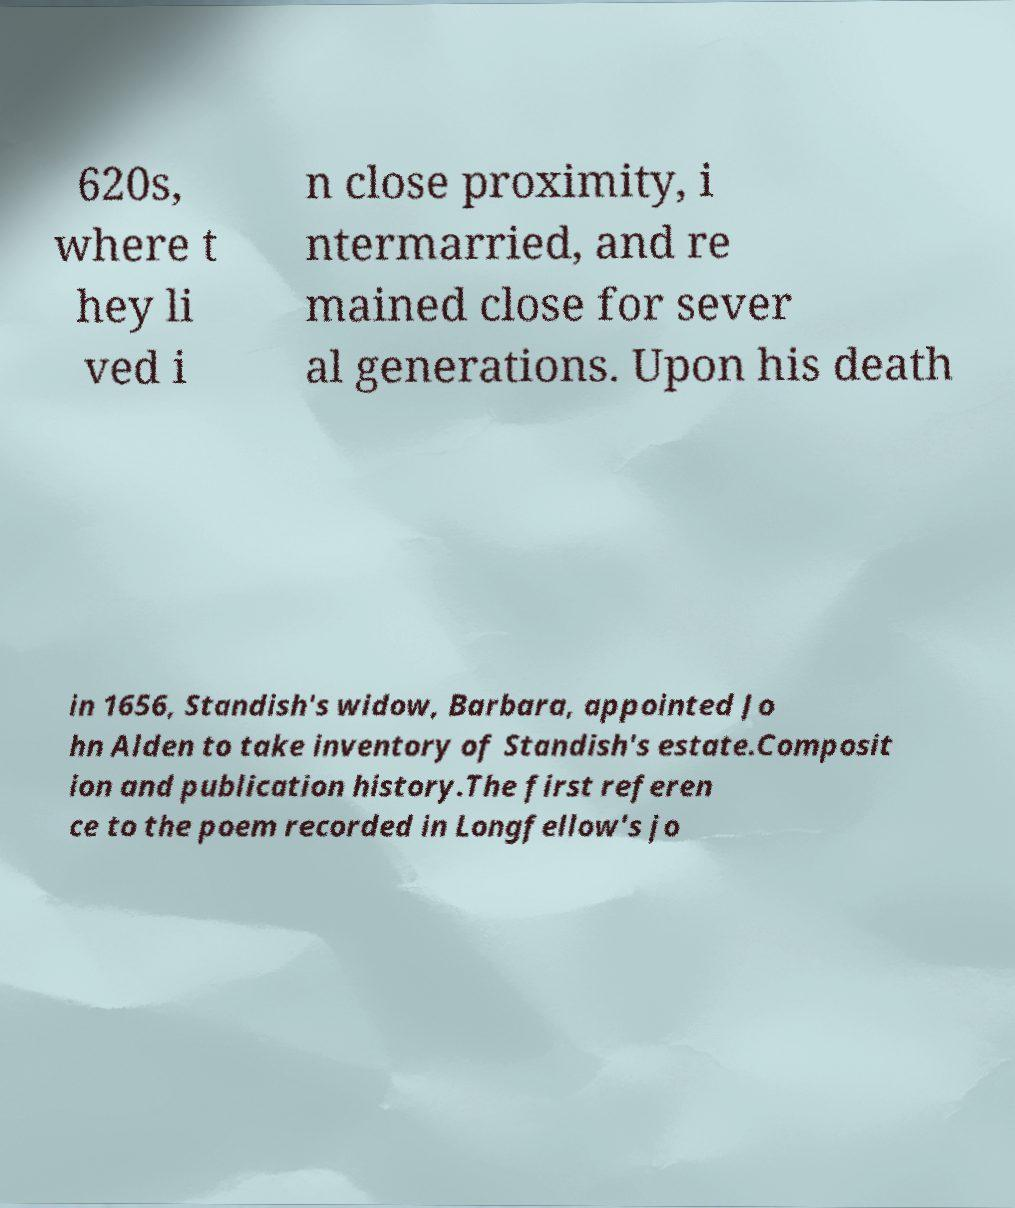Could you extract and type out the text from this image? 620s, where t hey li ved i n close proximity, i ntermarried, and re mained close for sever al generations. Upon his death in 1656, Standish's widow, Barbara, appointed Jo hn Alden to take inventory of Standish's estate.Composit ion and publication history.The first referen ce to the poem recorded in Longfellow's jo 